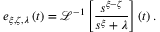Convert formula to latex. <formula><loc_0><loc_0><loc_500><loc_500>e _ { \xi , \zeta , \lambda } \left ( t \right ) = \mathcal { L } ^ { - 1 } \left [ \frac { s ^ { \xi - \zeta } } { s ^ { \xi } + \lambda } \right ] \left ( t \right ) .</formula> 